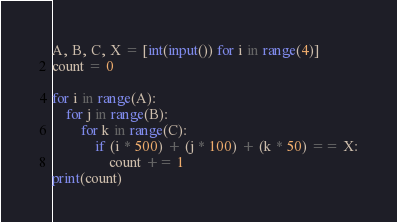<code> <loc_0><loc_0><loc_500><loc_500><_Python_>A, B, C, X = [int(input()) for i in range(4)]
count = 0

for i in range(A):
    for j in range(B):
        for k in range(C):
            if (i * 500) + (j * 100) + (k * 50) == X:
                count += 1
print(count)</code> 